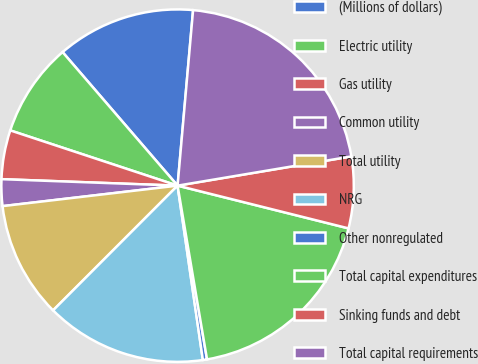Convert chart to OTSL. <chart><loc_0><loc_0><loc_500><loc_500><pie_chart><fcel>(Millions of dollars)<fcel>Electric utility<fcel>Gas utility<fcel>Common utility<fcel>Total utility<fcel>NRG<fcel>Other nonregulated<fcel>Total capital expenditures<fcel>Sinking funds and debt<fcel>Total capital requirements<nl><fcel>12.72%<fcel>8.61%<fcel>4.49%<fcel>2.44%<fcel>10.66%<fcel>14.78%<fcel>0.38%<fcel>18.43%<fcel>6.55%<fcel>20.95%<nl></chart> 